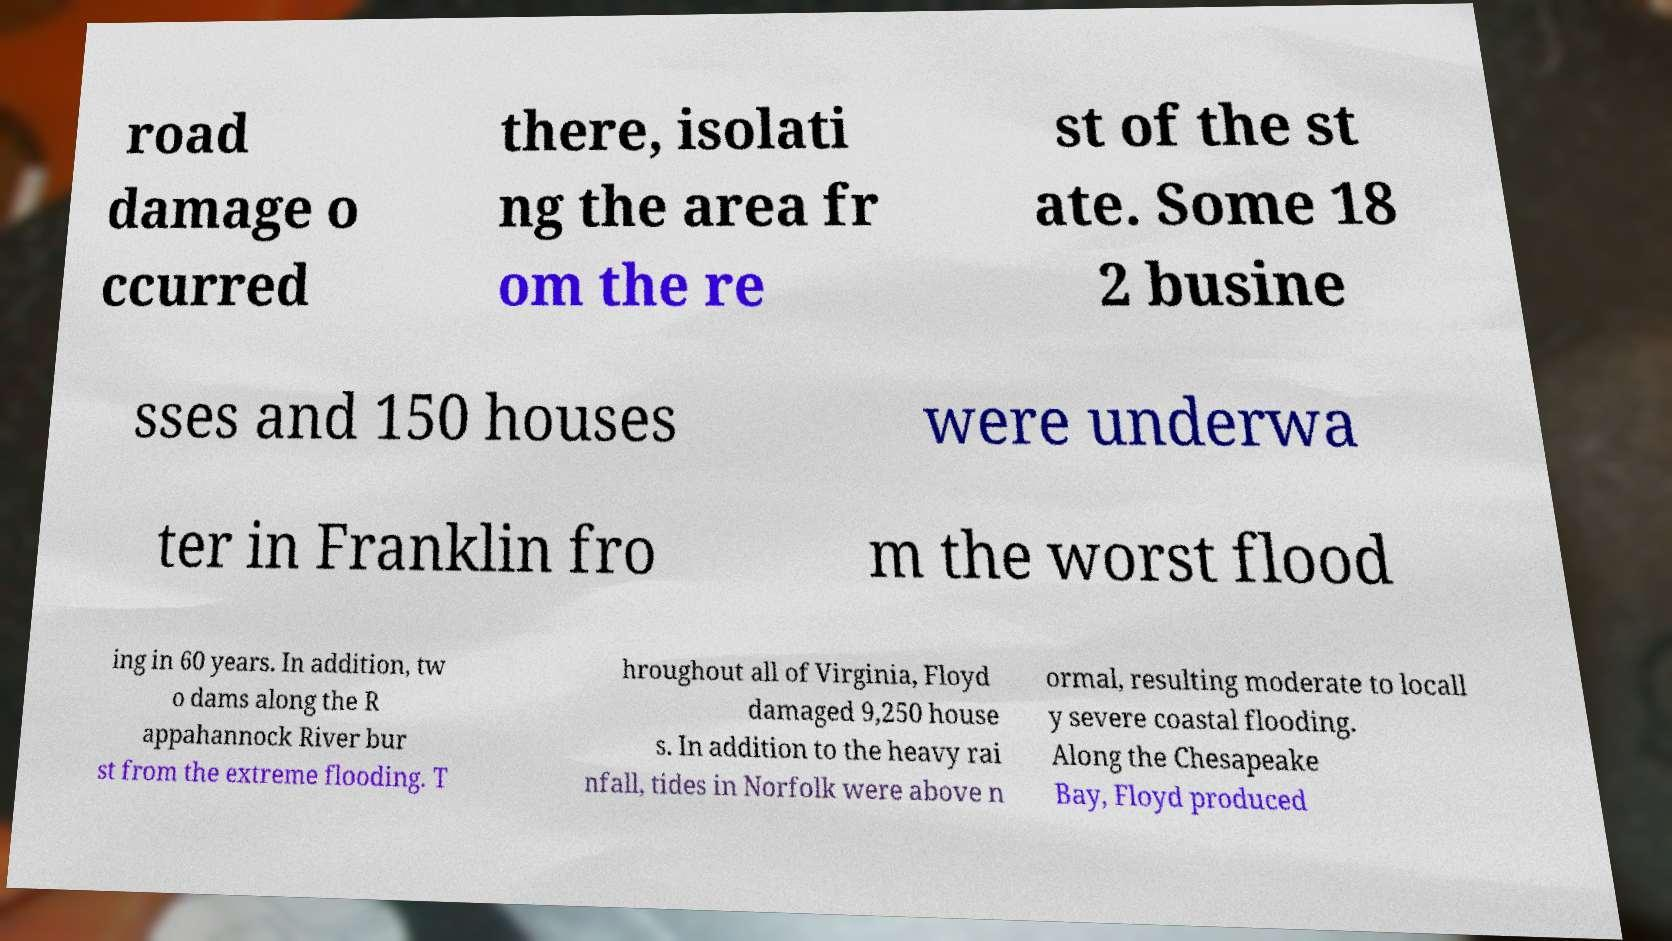Can you accurately transcribe the text from the provided image for me? road damage o ccurred there, isolati ng the area fr om the re st of the st ate. Some 18 2 busine sses and 150 houses were underwa ter in Franklin fro m the worst flood ing in 60 years. In addition, tw o dams along the R appahannock River bur st from the extreme flooding. T hroughout all of Virginia, Floyd damaged 9,250 house s. In addition to the heavy rai nfall, tides in Norfolk were above n ormal, resulting moderate to locall y severe coastal flooding. Along the Chesapeake Bay, Floyd produced 